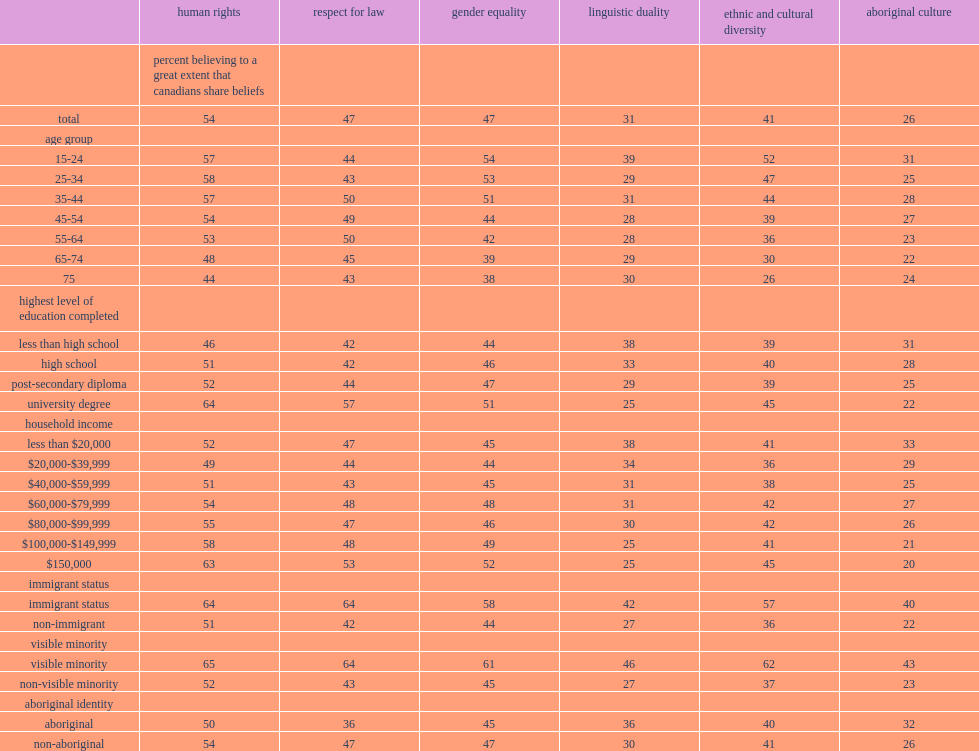Before the age of 25, what percent of people strongly believed that canadians valued ethnic and cultural diversity? 52.0. By age 75, what percent of canadians greatly felt that they value human rights? 44.0. Under age 25, what percent of canadian greatly felt that they value human rights? 57.0. What percent of the university-educated population strongly felt that canadians valued human rights? 64.0. What percent of the propotion recorded for the population with a university degree was higher than the proportion recorded for the population with a post-secondary diploma? 12. What percent of people with a household income of less than $20,000 believed to a great extent that canadians respected aboriginal culture? 33.0. What percent of people with household incomes between $60,000 and $79,999 believed to a great extent that canadians respected aboriginal culture? 27.0. What percent of immigrants said they greatly believed canadians valued english and french as official languages? 42.0. As for respect for aboriginal culture, wha percent of immigrants believed to a great extent that canadians shared this value? 40.0. What percent of visible minorities strongly believed that canadians valued multiculturalism? 62.0. Which group of people were less likely to greatly believe that canadians had respect for the law? non-aboriginal people or aboriginal people? Aboriginal. Which group of people was as likely to greatly believe in the values of gender equality and ethnic and cultural diversity. Aboriginal. Which group of people was more likely to feel to a great extent that canadians respected aboriginal culture? aboriginal people or non-aboriginal people? Aboriginal. 